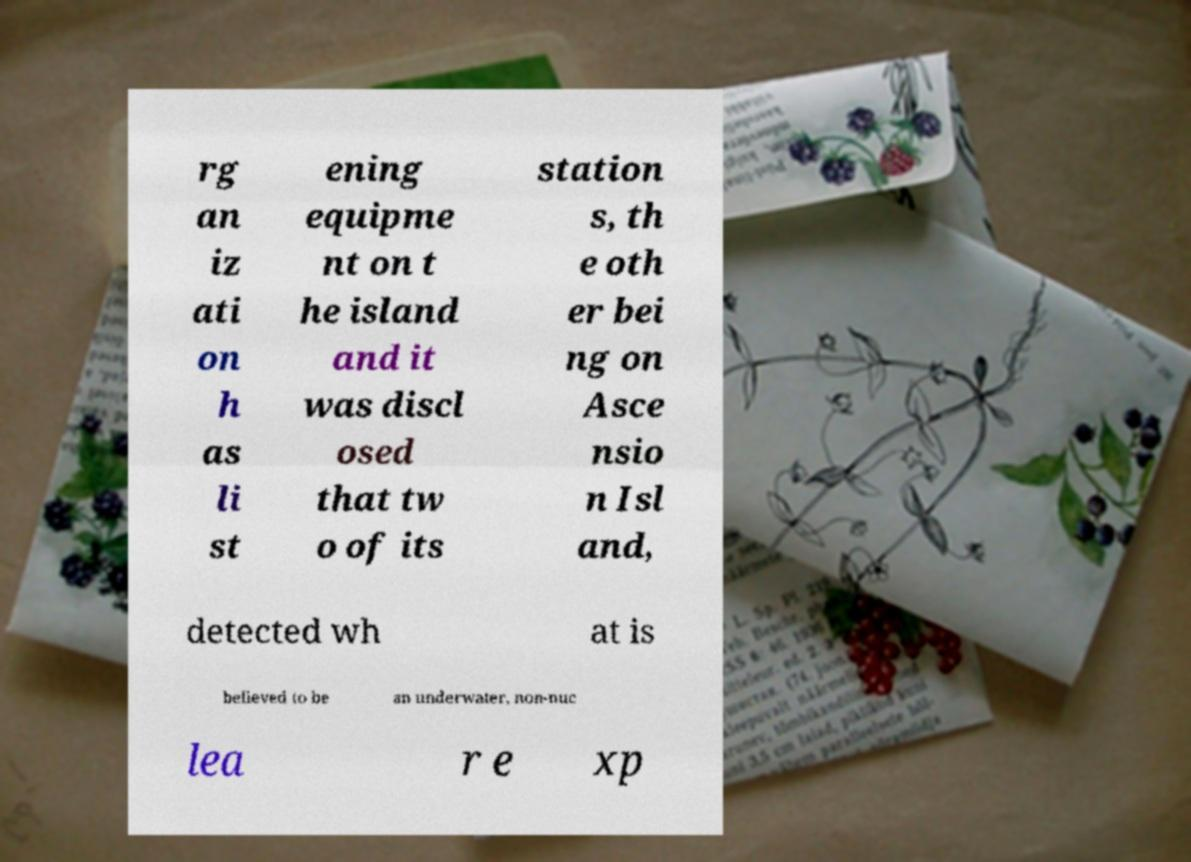Can you accurately transcribe the text from the provided image for me? rg an iz ati on h as li st ening equipme nt on t he island and it was discl osed that tw o of its station s, th e oth er bei ng on Asce nsio n Isl and, detected wh at is believed to be an underwater, non-nuc lea r e xp 